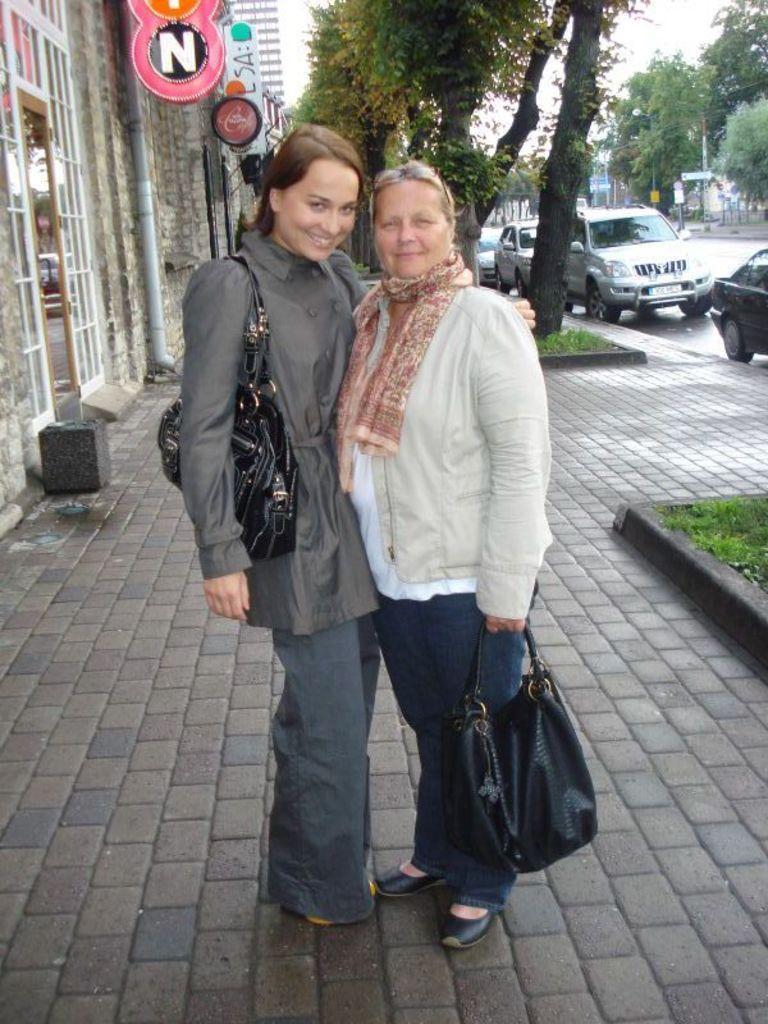Can you describe this image briefly? This is the picture of two women They are both standing on a sidewalk, the left side woman wears a bag while the right side woman holding a bag in her hands in the background we can see some buildings hoardings, sign boards, trees and cars. 